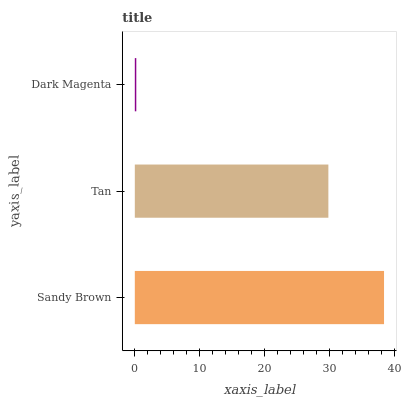Is Dark Magenta the minimum?
Answer yes or no. Yes. Is Sandy Brown the maximum?
Answer yes or no. Yes. Is Tan the minimum?
Answer yes or no. No. Is Tan the maximum?
Answer yes or no. No. Is Sandy Brown greater than Tan?
Answer yes or no. Yes. Is Tan less than Sandy Brown?
Answer yes or no. Yes. Is Tan greater than Sandy Brown?
Answer yes or no. No. Is Sandy Brown less than Tan?
Answer yes or no. No. Is Tan the high median?
Answer yes or no. Yes. Is Tan the low median?
Answer yes or no. Yes. Is Dark Magenta the high median?
Answer yes or no. No. Is Sandy Brown the low median?
Answer yes or no. No. 